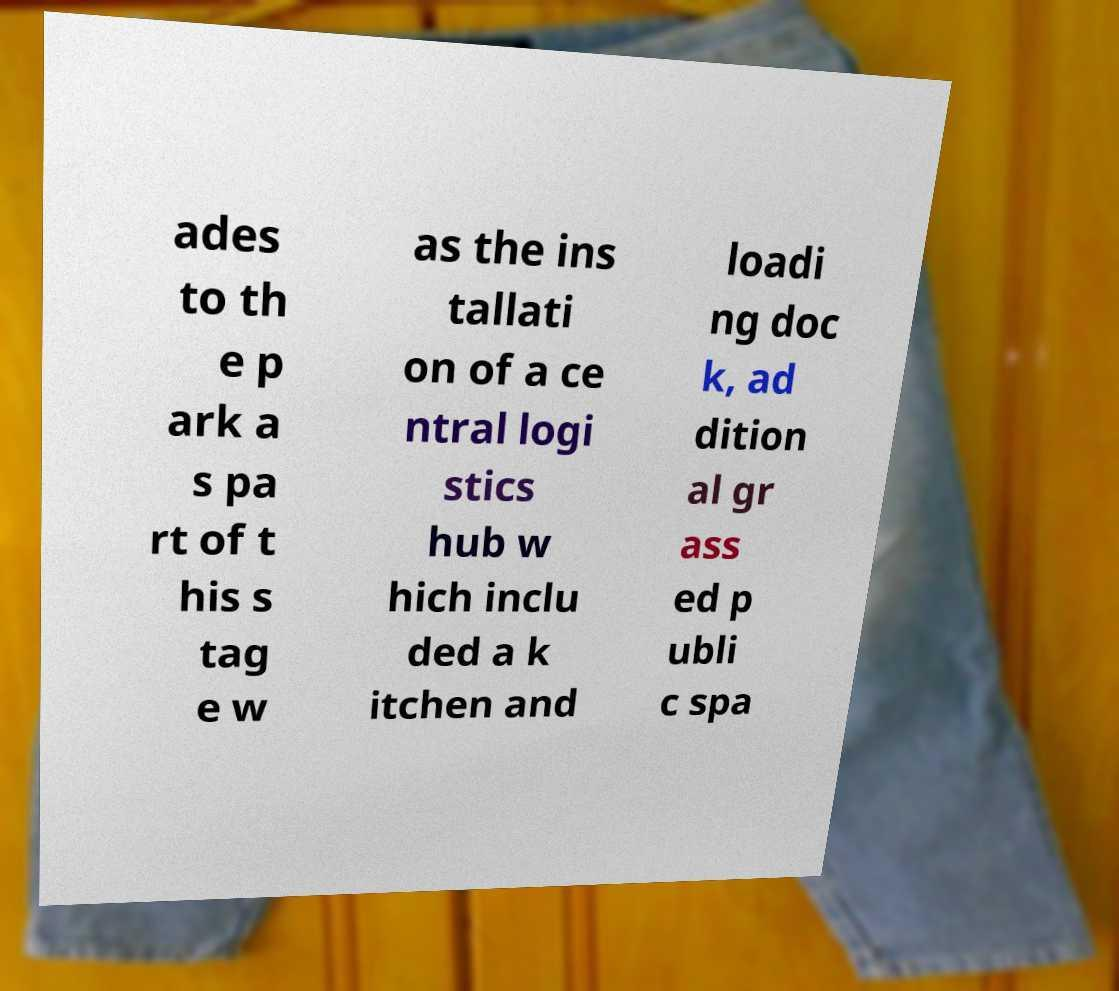Please identify and transcribe the text found in this image. ades to th e p ark a s pa rt of t his s tag e w as the ins tallati on of a ce ntral logi stics hub w hich inclu ded a k itchen and loadi ng doc k, ad dition al gr ass ed p ubli c spa 